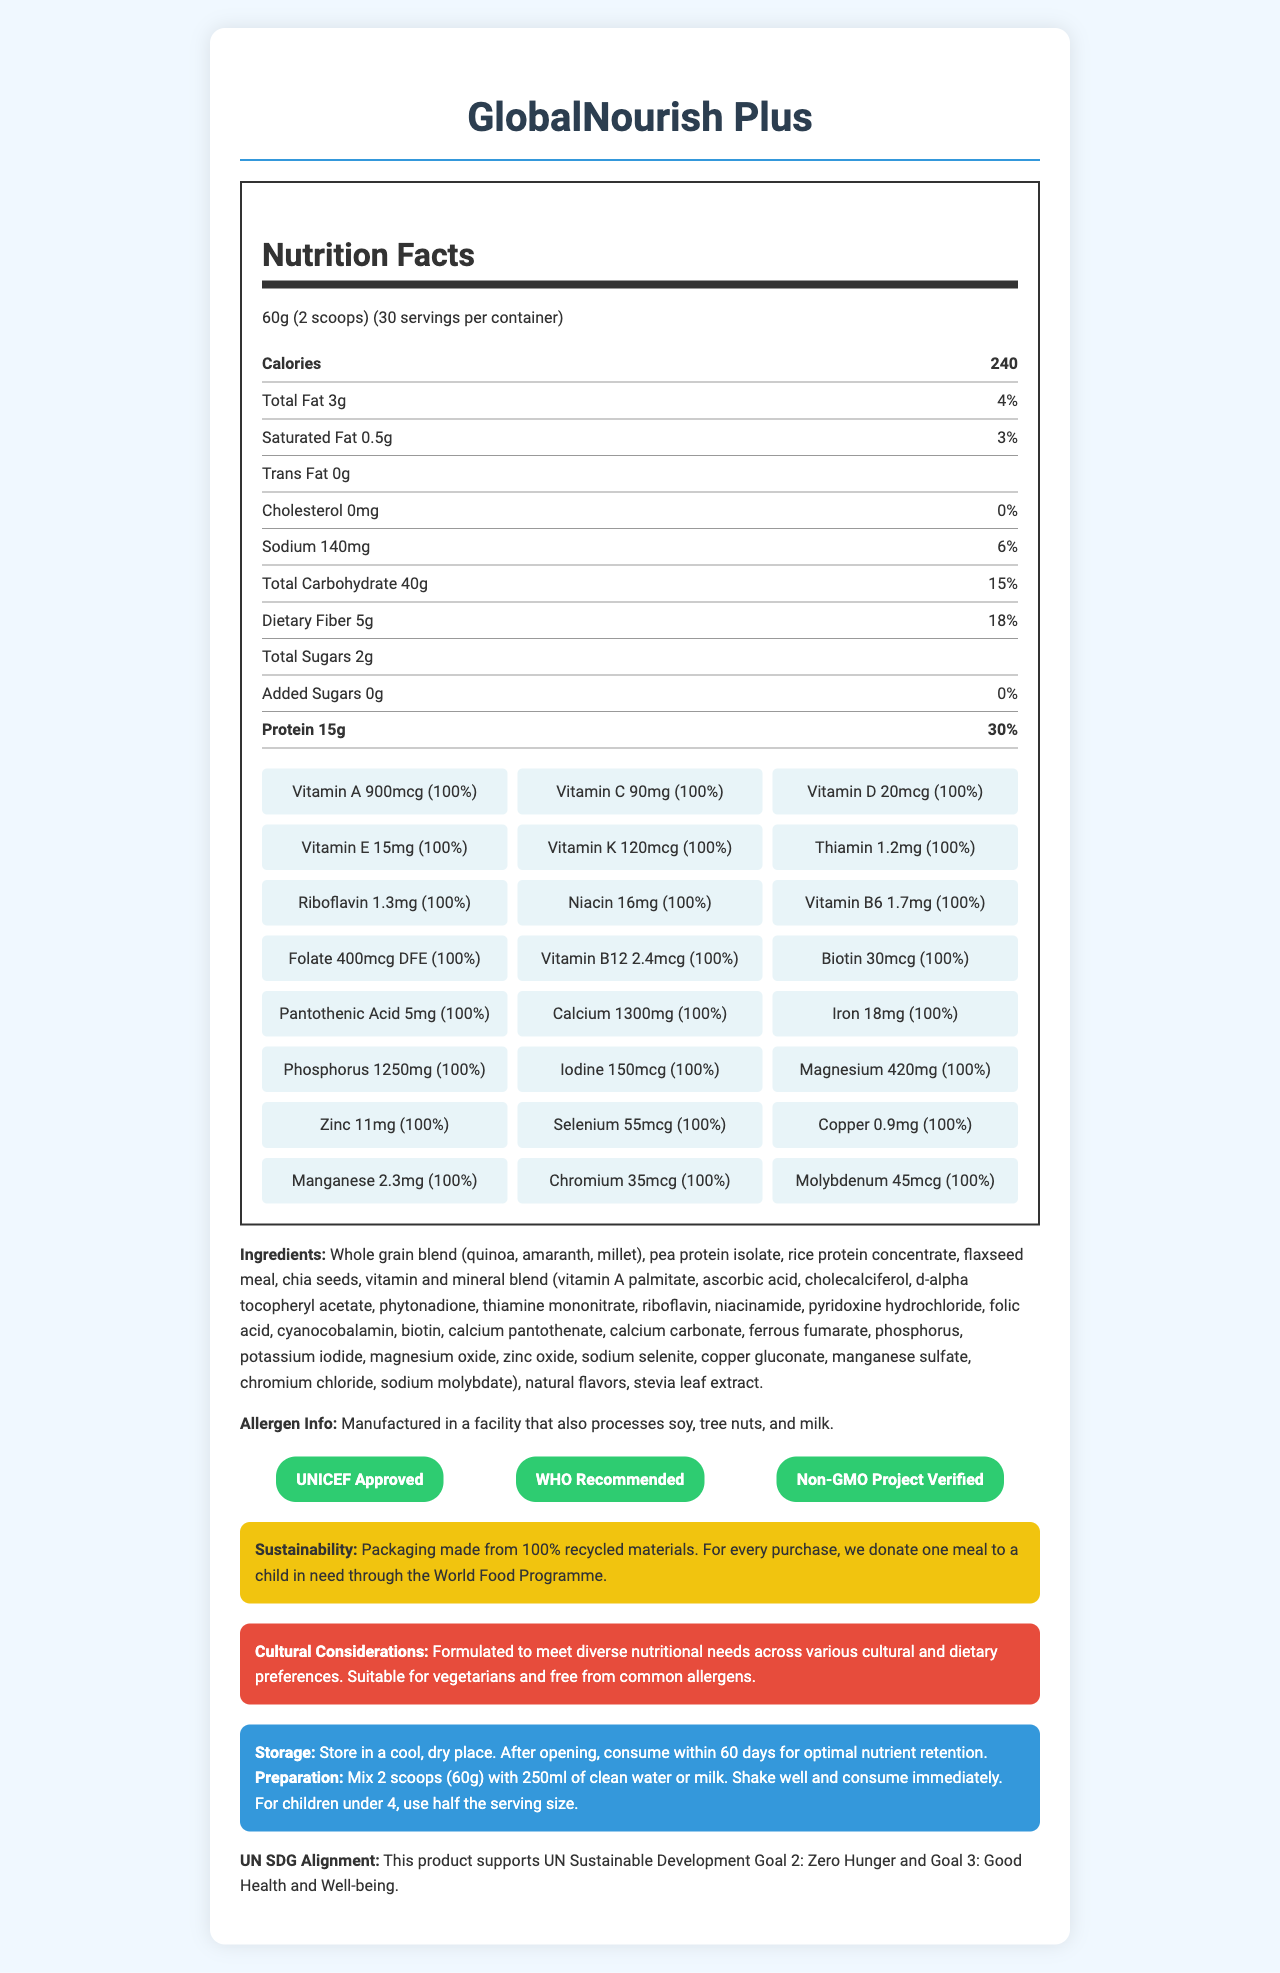what is the serving size of GlobalNourish Plus? The document clearly states that the serving size for GlobalNourish Plus is 60g, which is equivalent to 2 scoops.
Answer: 60g (2 scoops) how many servings per container are there? The document mentions that there are 30 servings per container of GlobalNourish Plus.
Answer: 30 how many calories are in one serving of GlobalNourish Plus? According to the nutrition facts, one serving of GlobalNourish Plus contains 240 calories.
Answer: 240 what is the amount of protein per serving and its percentage of daily value? The document specifies that each serving has 15g of protein, which is 30% of the daily value.
Answer: 15g, 30% what are the added sugars per serving? The nutrition label indicates that there are 0 grams of added sugars per serving.
Answer: 0g is this product suitable for vegetarians? The document mentions that GlobalNourish Plus is formulated to be suitable for vegetarians.
Answer: Yes which of the following certificates does the product have? (select all that apply) A. USDA Organic B. UNICEF Approved C. WHO Recommended D. Non-GMO Project Verified The document lists UNICEF Approved, WHO Recommended, and Non-GMO Project Verified as certifications.
Answer: B, C, D what is the total fat content and its daily value percentage per serving? The document states that the total fat content per serving is 3g, which is 4% of the daily value.
Answer: 3g, 4% what percentage of the daily value of vitamin C does one serving provide? A. 50% B. 75% C. 100% D. 125% The document specifies that one serving provides 100% of the daily value for vitamin C.
Answer: C. 100% does the product contain any trans fat? The nutrition facts label shows that the trans fat amount is 0g.
Answer: No what vitamins and minerals have 100% of the daily value in one serving? The document lists these vitamins and minerals as having 100% of the daily value in one serving.
Answer: Vitamin A, Vitamin C, Vitamin D, Vitamin E, Vitamin K, Thiamin, Riboflavin, Niacin, Vitamin B6, Folate, Vitamin B12, Biotin, Pantothenic Acid, Calcium, Iron, Phosphorus, Iodine, Magnesium, Zinc, Selenium, Copper, Manganese, Chromium, Molybdenum what are the main benefits highlighted by the document? The document discusses the product’s alignment with UN SDG 2 and 3, its certifications, sustainability features, and suitability for different diets and cultures.
Answer: The document emphasizes that GlobalNourish Plus supports UN Sustainable Development Goals, is suitable for diverse dietary needs, free from common allergens, and is environmentally sustainable. how should GlobalNourish Plus be stored after opening? According to the document, the product should be stored in a cool, dry place and consumed within 60 days after opening for optimal nutrient retention.
Answer: Consume within 60 days is the product safe for children under 4 years old? The preparation instructions state that for children under 4, half the serving size should be used.
Answer: Yes, with half the serving size what are the exact quantities of sodium and dietary fiber per serving? The document details sodium as 140mg and dietary fiber as 5g per serving.
Answer: Sodium: 140mg, Dietary Fiber: 5g are there any allergens processed in the same facility? The allergen information indicates that the product is manufactured in a facility that also processes soy, tree nuts, and milk.
Answer: Yes, soy, tree nuts, and milk is GlobalNourish Plus gluten-free? The document does not provide explicit information about whether GlobalNourish Plus is gluten-free.
Answer: Not enough information describe the main nutritional and supplementary benefits of GlobalNourish Plus as indicated in the document. The GlobalNourish Plus document outlines the product’s comprehensive nutritional profile and its alignment with global health and sustainability goals. It is designed to be inclusive of various dietary requirements while providing extensive micronutrient content to support overall health.
Answer: The document highlights that GlobalNourish Plus is a well-rounded food supplement providing 100% of the daily value for various essential vitamins and minerals. It aims to combat global hunger while supporting health and well-being, aligning with UN Sustainable Development Goals. The product is suitable for diverse dietary needs and free from common allergens. It includes significant amounts of protein, dietary fiber, and vitamins like A, C, D, E, and K, minerals like calcium, iron, and magnesium, and is backed by UNICEF, WHO, and Non-GMO Project certifications. Additionally, its packaging is environmentally friendly. 